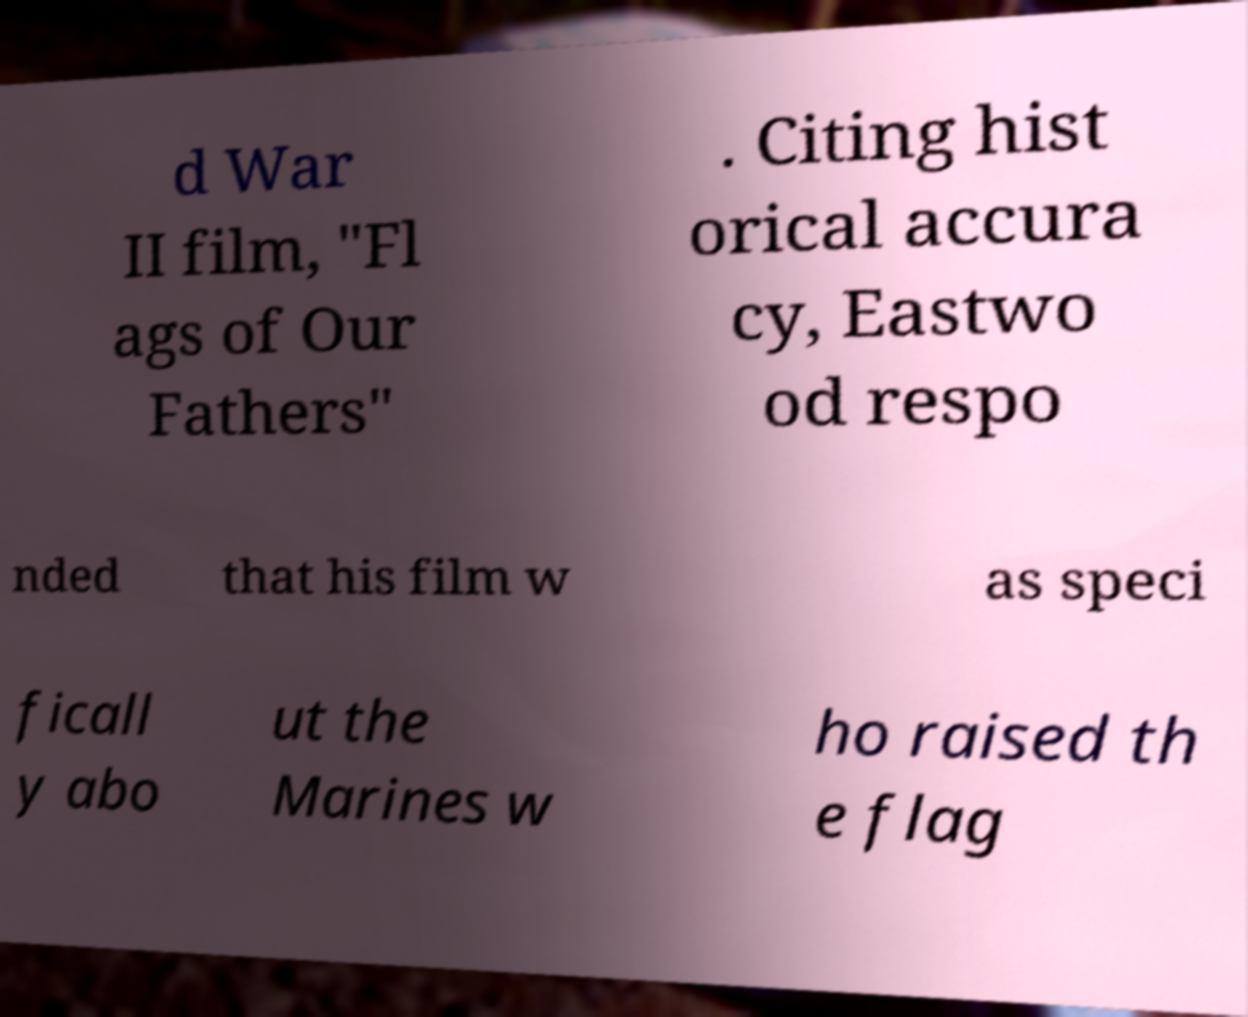Could you extract and type out the text from this image? d War II film, "Fl ags of Our Fathers" . Citing hist orical accura cy, Eastwo od respo nded that his film w as speci ficall y abo ut the Marines w ho raised th e flag 